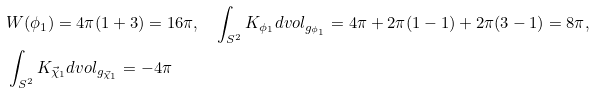Convert formula to latex. <formula><loc_0><loc_0><loc_500><loc_500>& W ( \phi _ { 1 } ) = 4 \pi ( 1 + 3 ) = 1 6 \pi , \quad \int _ { S ^ { 2 } } K _ { \phi _ { 1 } } d v o l _ { g _ { \phi _ { 1 } } } = 4 \pi + 2 \pi ( 1 - 1 ) + 2 \pi ( 3 - 1 ) = 8 \pi , \\ & \int _ { S ^ { 2 } } K _ { \vec { \chi } _ { 1 } } d v o l _ { g _ { \vec { \chi } _ { 1 } } } = - 4 \pi</formula> 